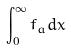<formula> <loc_0><loc_0><loc_500><loc_500>\int _ { 0 } ^ { \infty } f _ { a } d x</formula> 